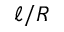<formula> <loc_0><loc_0><loc_500><loc_500>\ell / R</formula> 